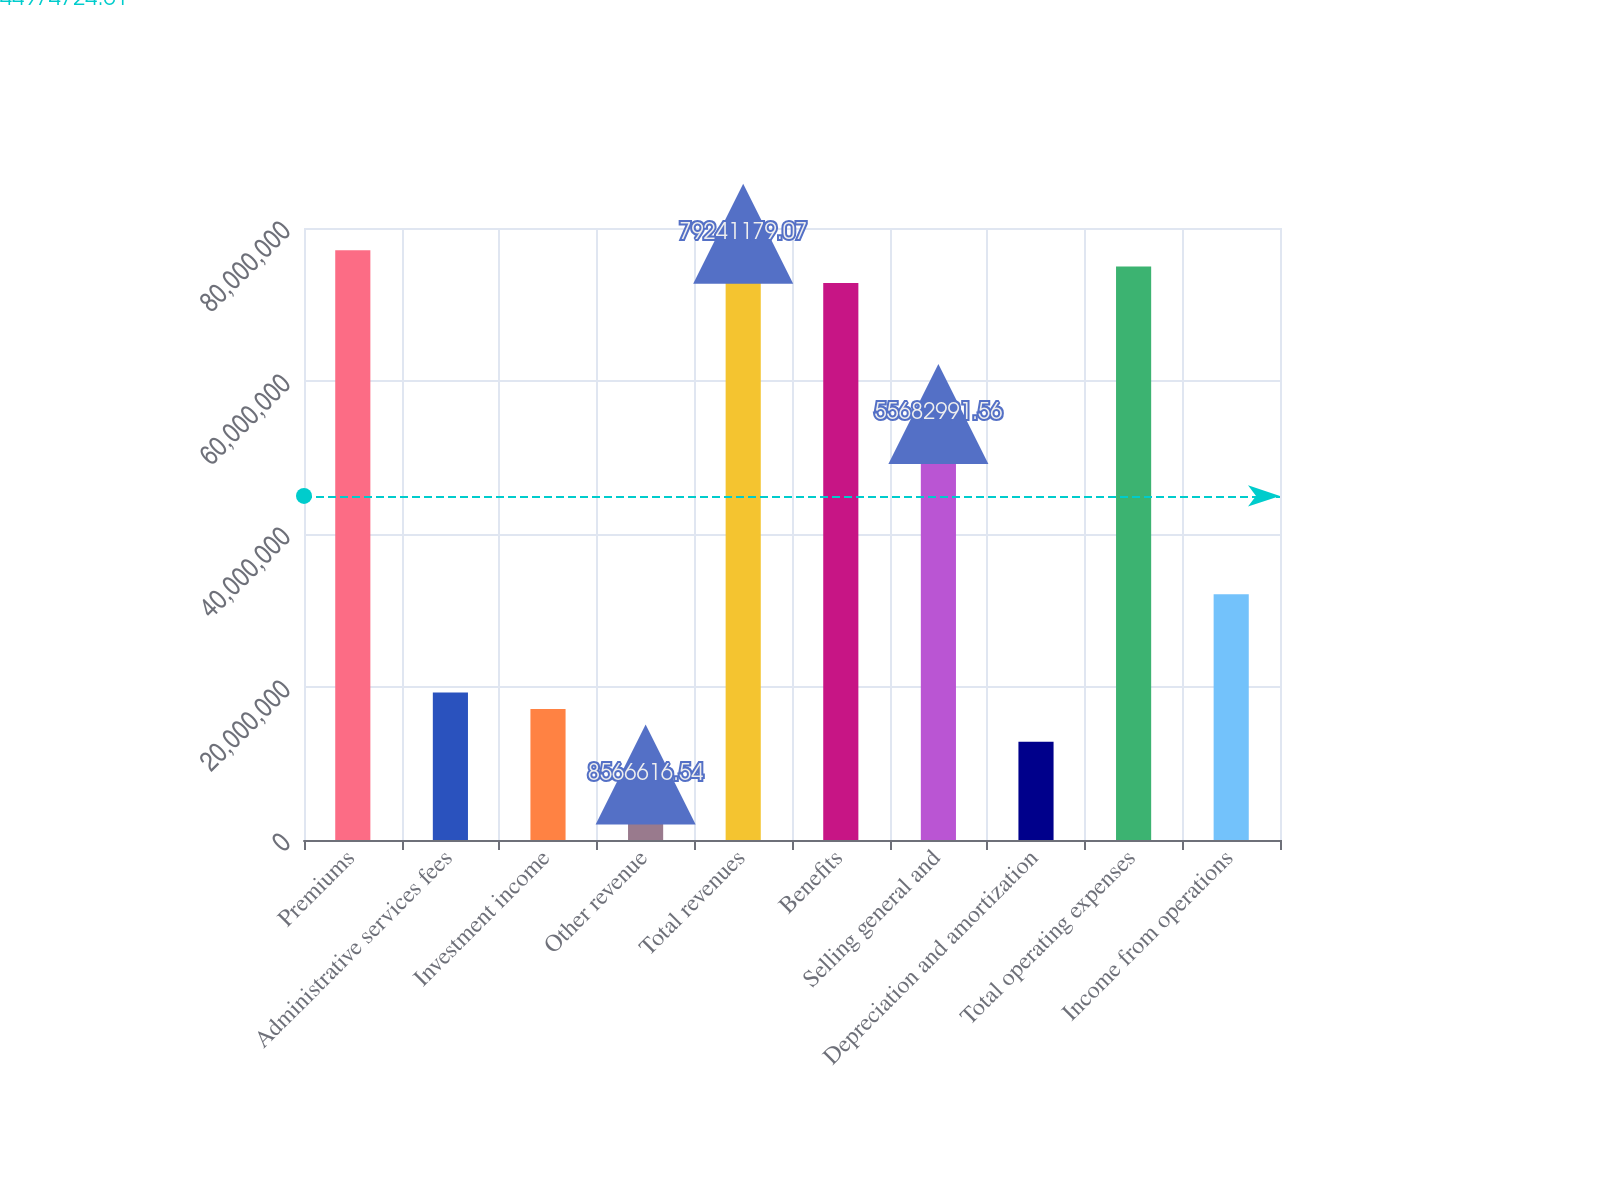Convert chart. <chart><loc_0><loc_0><loc_500><loc_500><bar_chart><fcel>Premiums<fcel>Administrative services fees<fcel>Investment income<fcel>Other revenue<fcel>Total revenues<fcel>Benefits<fcel>Selling general and<fcel>Depreciation and amortization<fcel>Total operating expenses<fcel>Income from operations<nl><fcel>7.70995e+07<fcel>1.92749e+07<fcel>1.71332e+07<fcel>8.56662e+06<fcel>7.92412e+07<fcel>7.28162e+07<fcel>5.5683e+07<fcel>1.28499e+07<fcel>7.49579e+07<fcel>3.21248e+07<nl></chart> 